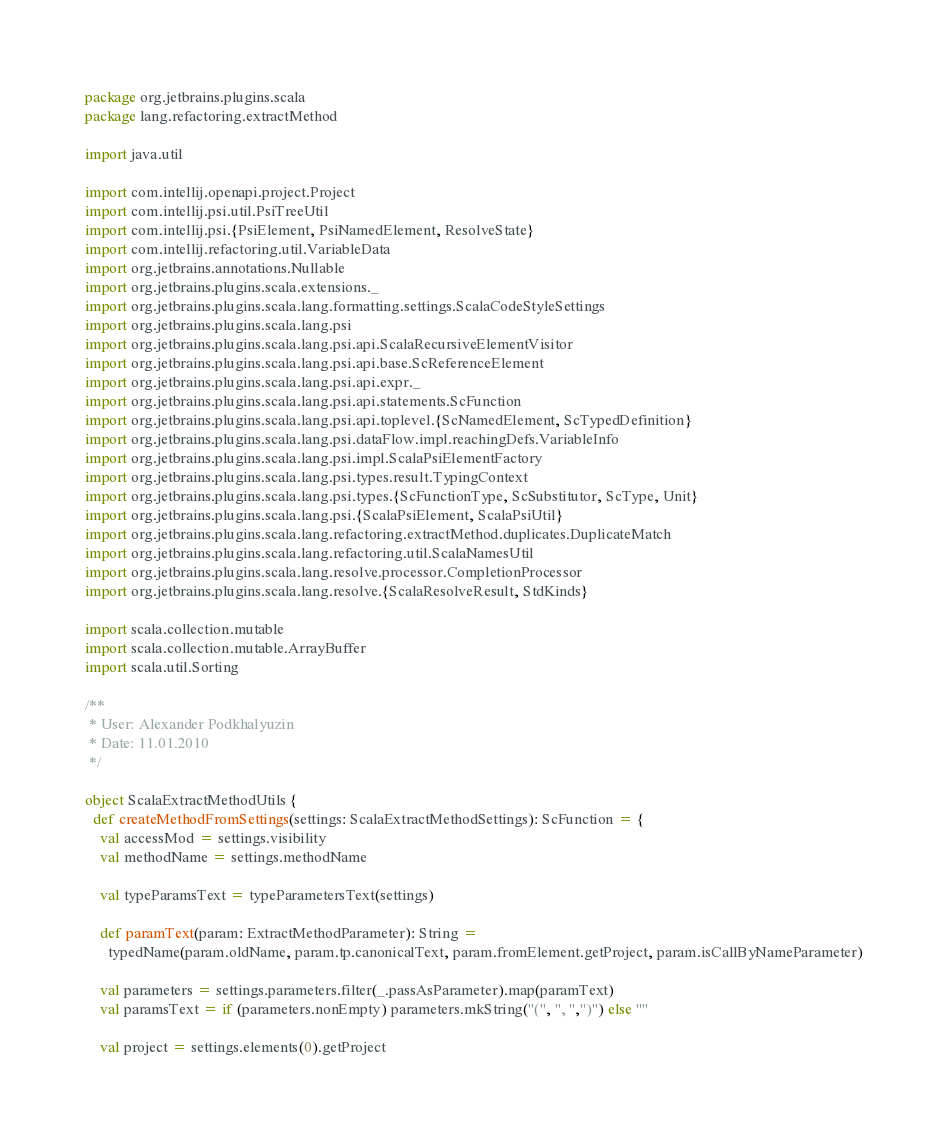<code> <loc_0><loc_0><loc_500><loc_500><_Scala_>package org.jetbrains.plugins.scala
package lang.refactoring.extractMethod

import java.util

import com.intellij.openapi.project.Project
import com.intellij.psi.util.PsiTreeUtil
import com.intellij.psi.{PsiElement, PsiNamedElement, ResolveState}
import com.intellij.refactoring.util.VariableData
import org.jetbrains.annotations.Nullable
import org.jetbrains.plugins.scala.extensions._
import org.jetbrains.plugins.scala.lang.formatting.settings.ScalaCodeStyleSettings
import org.jetbrains.plugins.scala.lang.psi
import org.jetbrains.plugins.scala.lang.psi.api.ScalaRecursiveElementVisitor
import org.jetbrains.plugins.scala.lang.psi.api.base.ScReferenceElement
import org.jetbrains.plugins.scala.lang.psi.api.expr._
import org.jetbrains.plugins.scala.lang.psi.api.statements.ScFunction
import org.jetbrains.plugins.scala.lang.psi.api.toplevel.{ScNamedElement, ScTypedDefinition}
import org.jetbrains.plugins.scala.lang.psi.dataFlow.impl.reachingDefs.VariableInfo
import org.jetbrains.plugins.scala.lang.psi.impl.ScalaPsiElementFactory
import org.jetbrains.plugins.scala.lang.psi.types.result.TypingContext
import org.jetbrains.plugins.scala.lang.psi.types.{ScFunctionType, ScSubstitutor, ScType, Unit}
import org.jetbrains.plugins.scala.lang.psi.{ScalaPsiElement, ScalaPsiUtil}
import org.jetbrains.plugins.scala.lang.refactoring.extractMethod.duplicates.DuplicateMatch
import org.jetbrains.plugins.scala.lang.refactoring.util.ScalaNamesUtil
import org.jetbrains.plugins.scala.lang.resolve.processor.CompletionProcessor
import org.jetbrains.plugins.scala.lang.resolve.{ScalaResolveResult, StdKinds}

import scala.collection.mutable
import scala.collection.mutable.ArrayBuffer
import scala.util.Sorting

/**
 * User: Alexander Podkhalyuzin
 * Date: 11.01.2010
 */

object ScalaExtractMethodUtils {
  def createMethodFromSettings(settings: ScalaExtractMethodSettings): ScFunction = {
    val accessMod = settings.visibility
    val methodName = settings.methodName

    val typeParamsText = typeParametersText(settings)

    def paramText(param: ExtractMethodParameter): String =
      typedName(param.oldName, param.tp.canonicalText, param.fromElement.getProject, param.isCallByNameParameter)

    val parameters = settings.parameters.filter(_.passAsParameter).map(paramText)
    val paramsText = if (parameters.nonEmpty) parameters.mkString("(", ", ",")") else ""

    val project = settings.elements(0).getProject</code> 